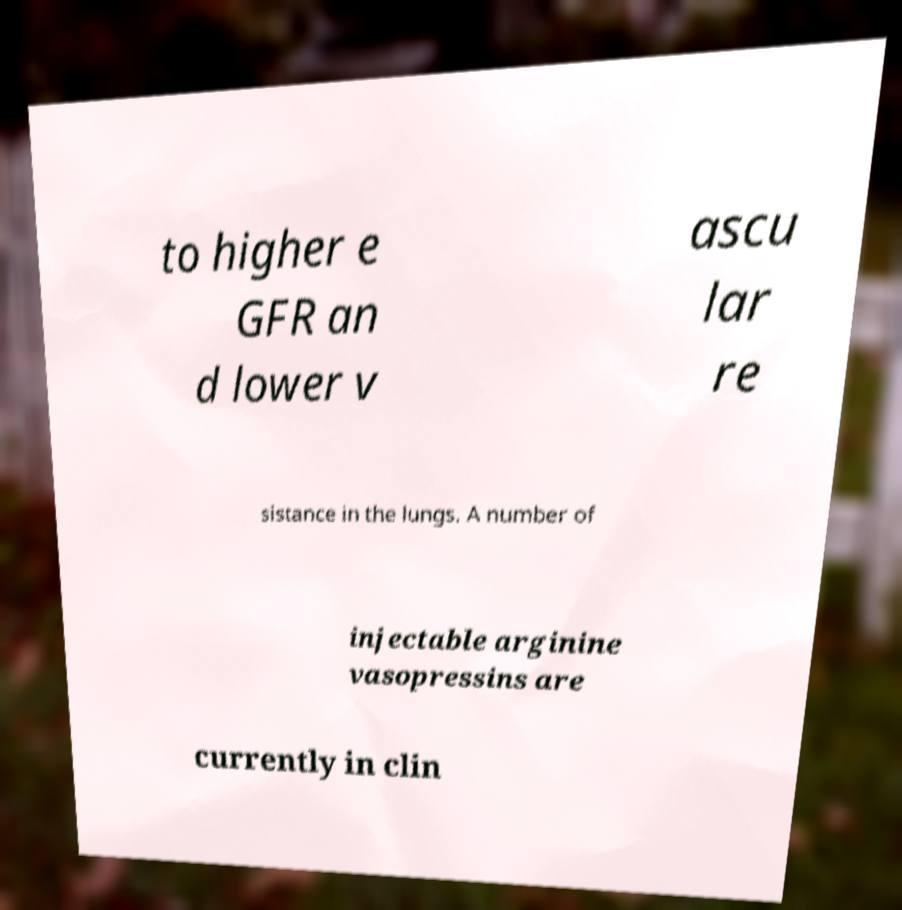Please identify and transcribe the text found in this image. to higher e GFR an d lower v ascu lar re sistance in the lungs. A number of injectable arginine vasopressins are currently in clin 